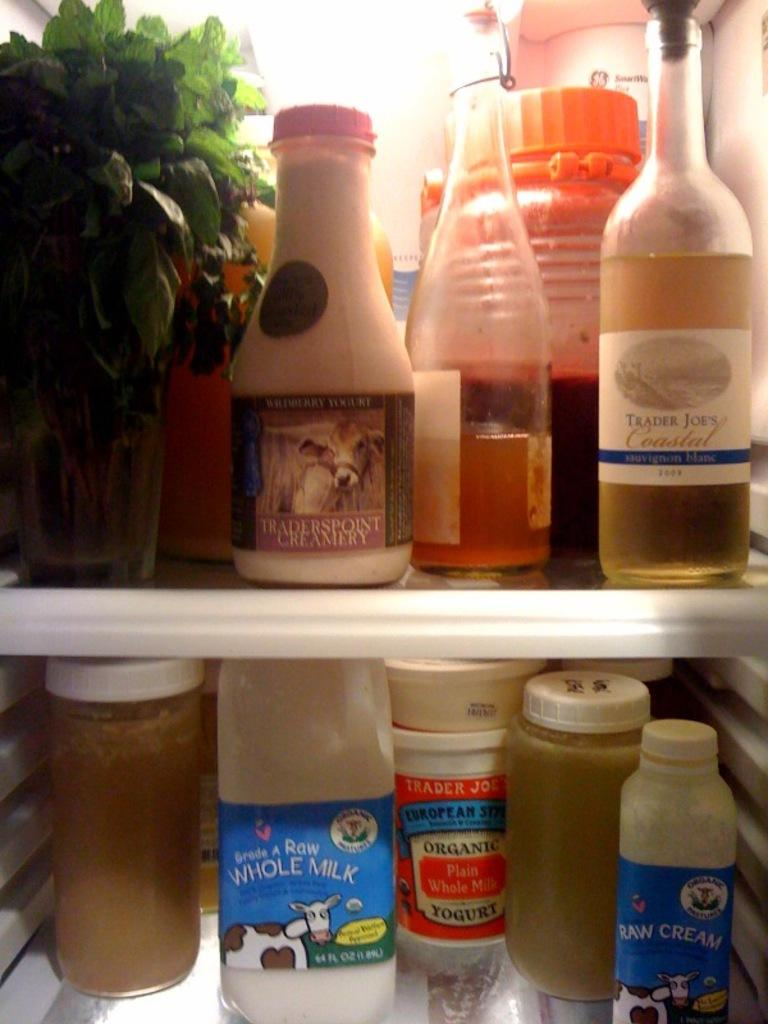<image>
Offer a succinct explanation of the picture presented. a fridge shelf that contains grade a raw whole milk 